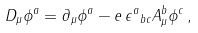<formula> <loc_0><loc_0><loc_500><loc_500>D _ { \mu } \phi ^ { a } = \partial _ { \mu } \phi ^ { a } - e \, { \epsilon ^ { a } } _ { b c } A _ { \mu } ^ { b } \phi ^ { c } \, ,</formula> 